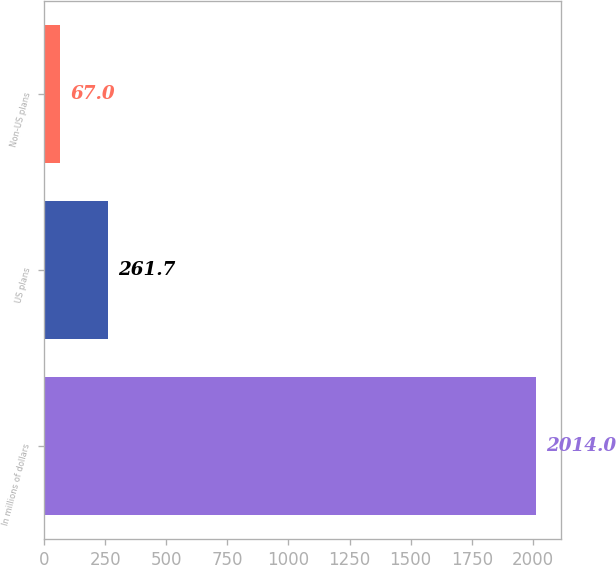<chart> <loc_0><loc_0><loc_500><loc_500><bar_chart><fcel>In millions of dollars<fcel>US plans<fcel>Non-US plans<nl><fcel>2014<fcel>261.7<fcel>67<nl></chart> 